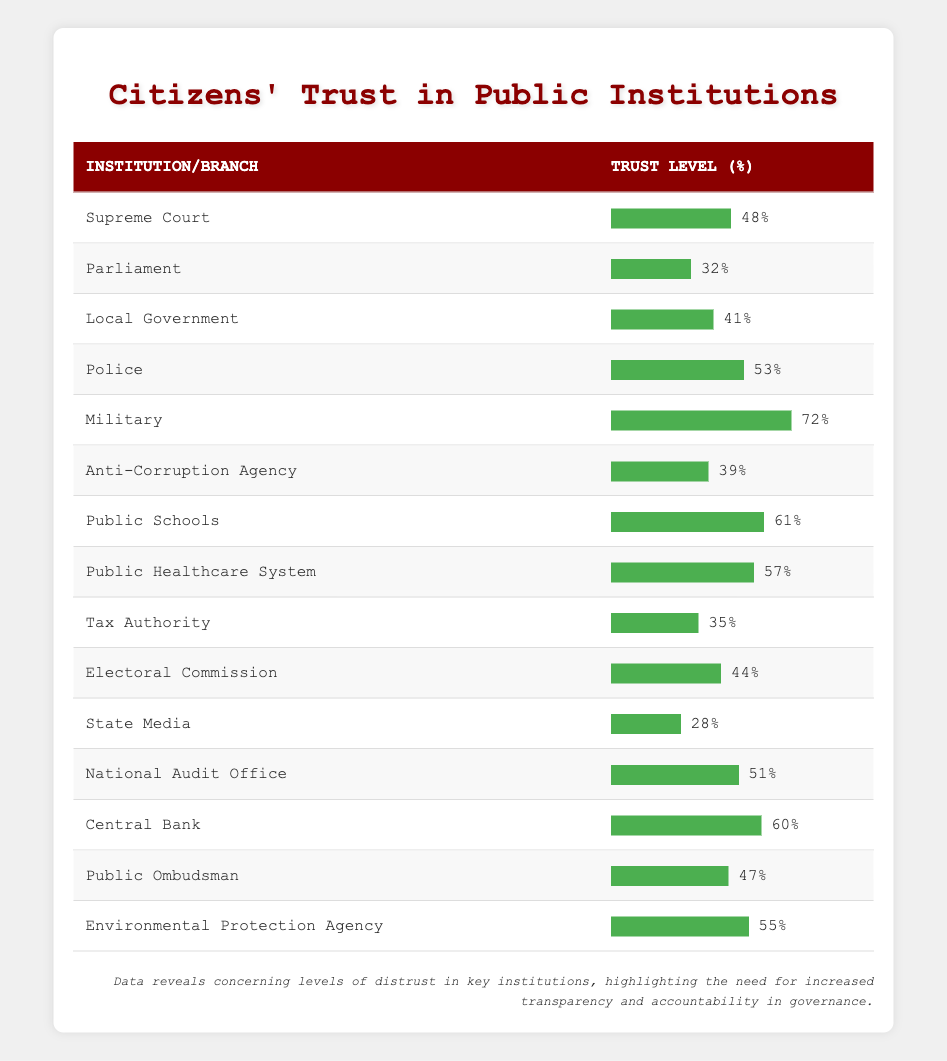What is the trust level in the Military? The trust level for the Military is listed directly in the table under the corresponding row, which shows 72%.
Answer: 72% Which institution has the lowest trust level? By reviewing the table, the State Media is the institution with the lowest trust level, recorded at 28%.
Answer: 28% What is the average trust level of the public healthcare system and public schools? To find the average, add the trust levels of Public Healthcare System (57%) and Public Schools (61%), which gives a total of 118%. Then divide by 2 (the number of institutions): 118% / 2 = 59%.
Answer: 59% Is the trust level in the Police higher than in the Electoral Commission? The trust level in the Police is 53% and for the Electoral Commission it is 44%. Since 53% is greater than 44%, the statement is true.
Answer: Yes If we consider the trust levels of Local Government and the Anti-Corruption Agency, which is higher and by how much? The trust level for Local Government is 41% and for the Anti-Corruption Agency it is 39%. The Local Government's trust level is higher by a difference of 2% (41% - 39% = 2%).
Answer: Higher by 2% Which two institutions have trust levels that are closest together? Upon reviewing the trust levels, the National Audit Office (51%) and the Supreme Court (48%) have the closest trust levels, just 3% apart (51% - 48% = 3%).
Answer: National Audit Office and Supreme Court What is the difference between the trust levels of the Central Bank and the Tax Authority? The trust level of the Central Bank is 60% and for the Tax Authority, it is 35%. The difference is calculated by subtracting the Tax Authority's level from the Central Bank's: 60% - 35% = 25%.
Answer: 25% What percentage of citizens trust the Anti-Corruption Agency more than the Parliament? The trust level of the Anti-Corruption Agency is 39% and for Parliament, it is 32%. Since 39% is greater than 32%, this indicates that citizens trust the Anti-Corruption Agency more.
Answer: Yes 